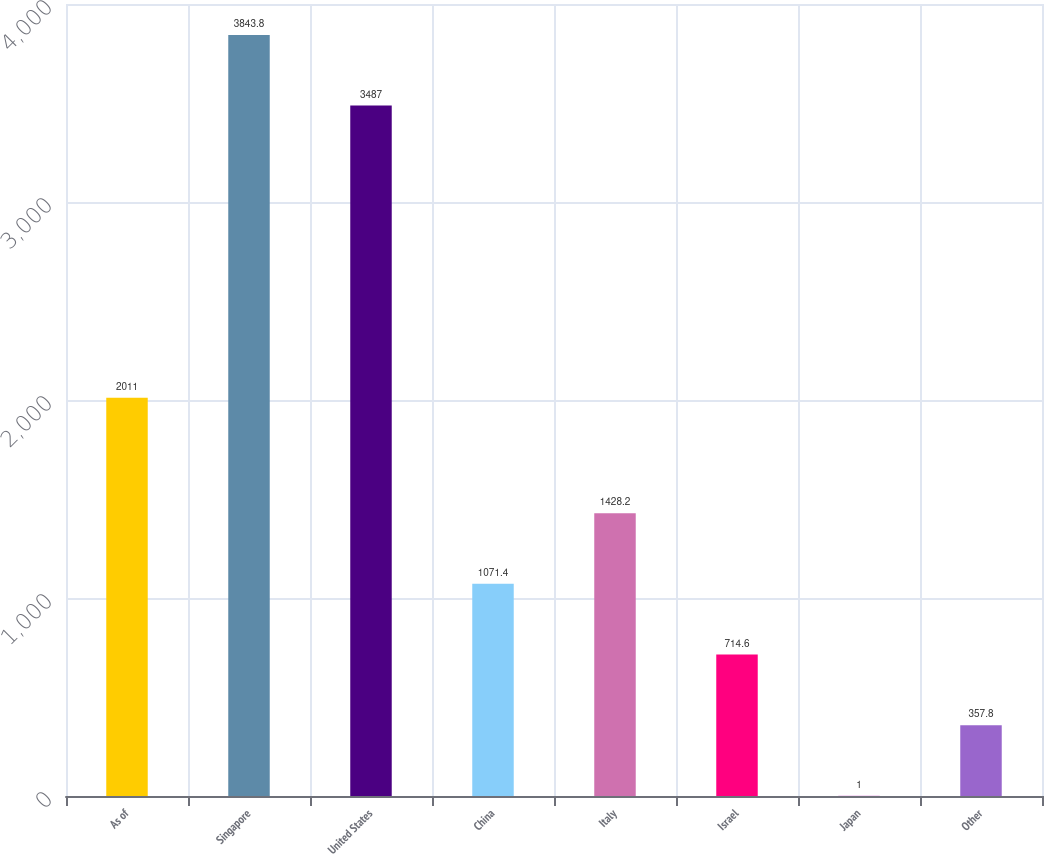Convert chart to OTSL. <chart><loc_0><loc_0><loc_500><loc_500><bar_chart><fcel>As of<fcel>Singapore<fcel>United States<fcel>China<fcel>Italy<fcel>Israel<fcel>Japan<fcel>Other<nl><fcel>2011<fcel>3843.8<fcel>3487<fcel>1071.4<fcel>1428.2<fcel>714.6<fcel>1<fcel>357.8<nl></chart> 